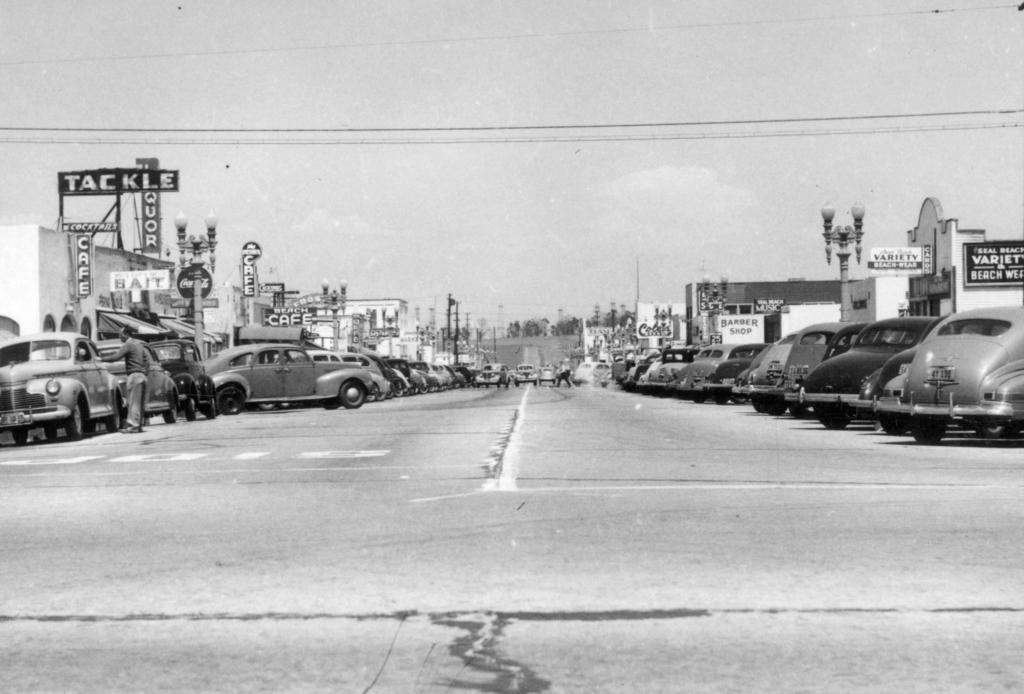Can you describe this image briefly? This is the picture of a place where we have some cars and around there are some buildings and some boards to the buildings. 